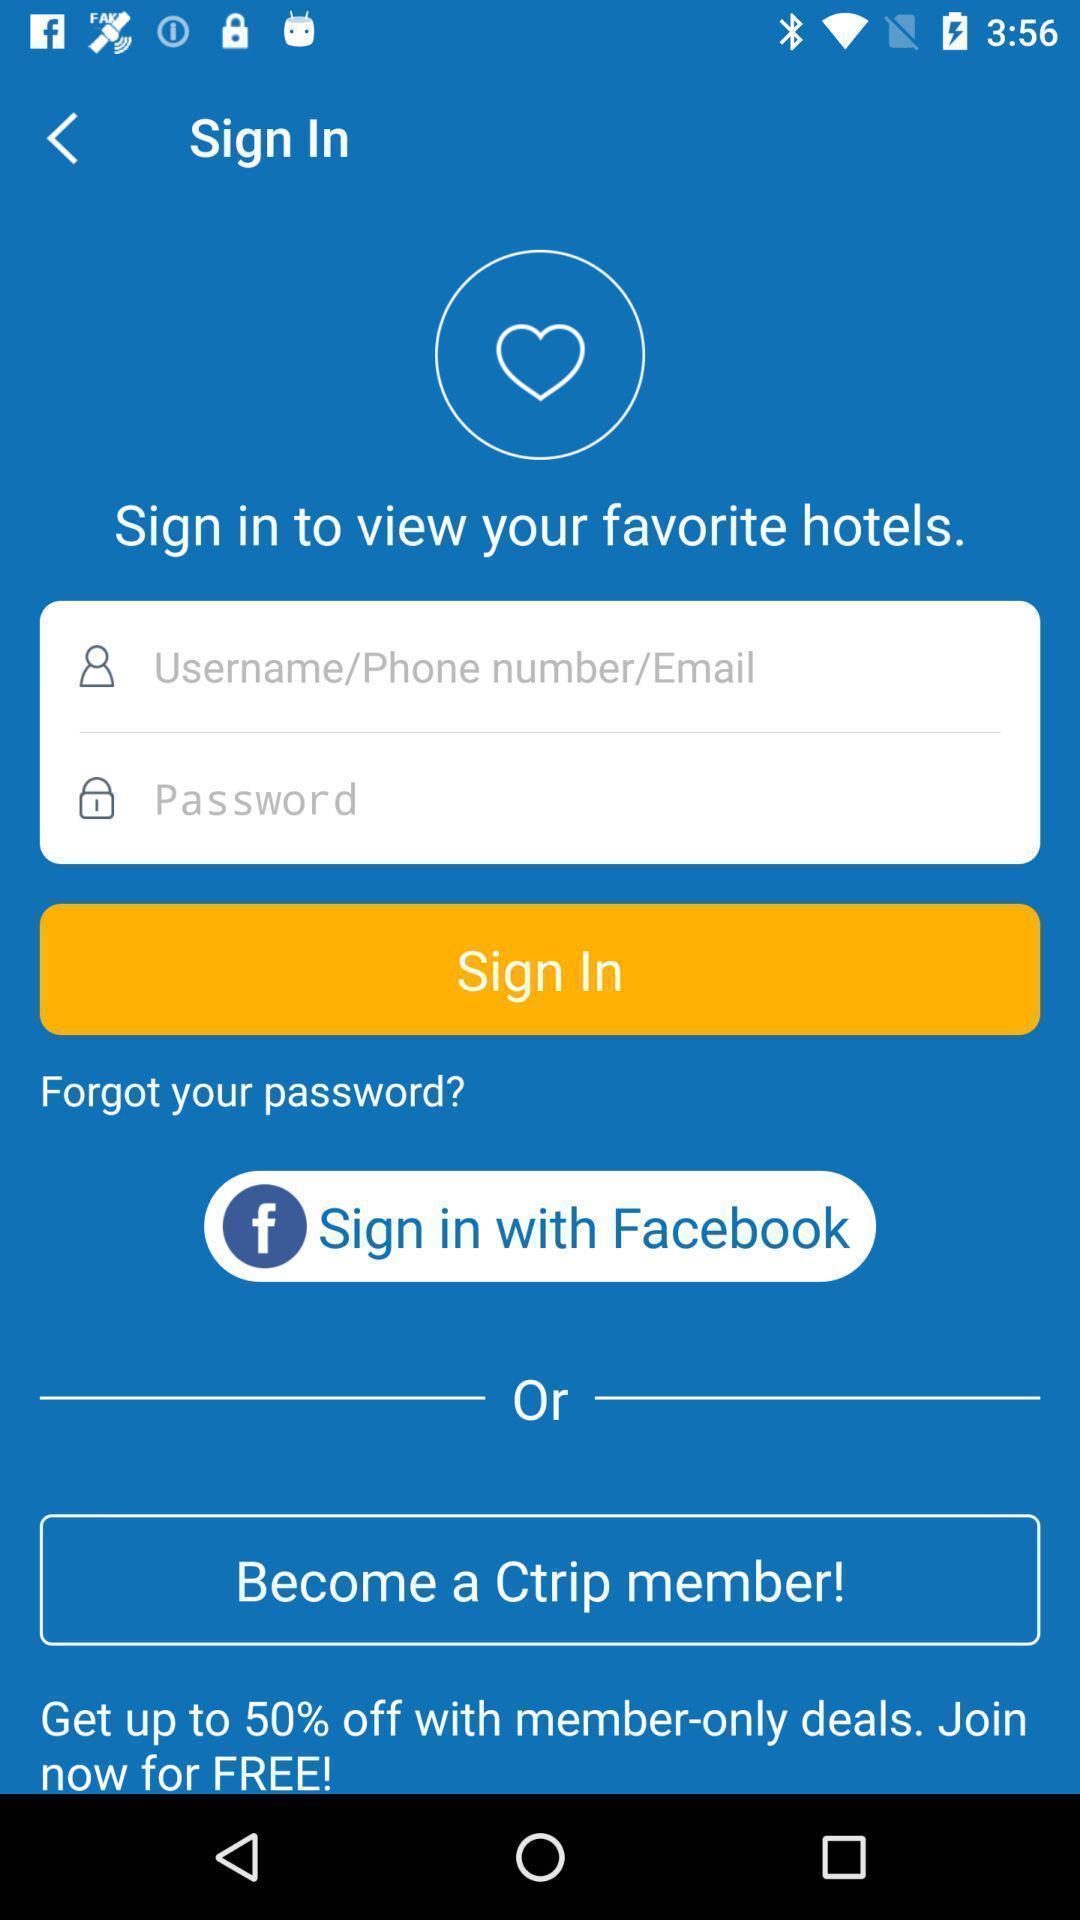What details can you identify in this image? Sign in page of the app. 